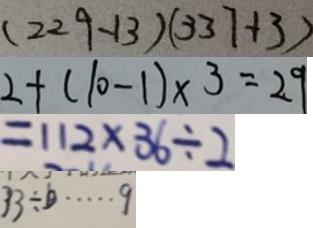<formula> <loc_0><loc_0><loc_500><loc_500>( 2 2 9 - 1 3 ) ( 3 3 7 + 3 ) 
 2 + ( 1 0 - 1 ) \times 3 = 2 9 
 = 1 1 2 \times 3 6 \div 2 
 3 3 \div b \cdots 9</formula> 